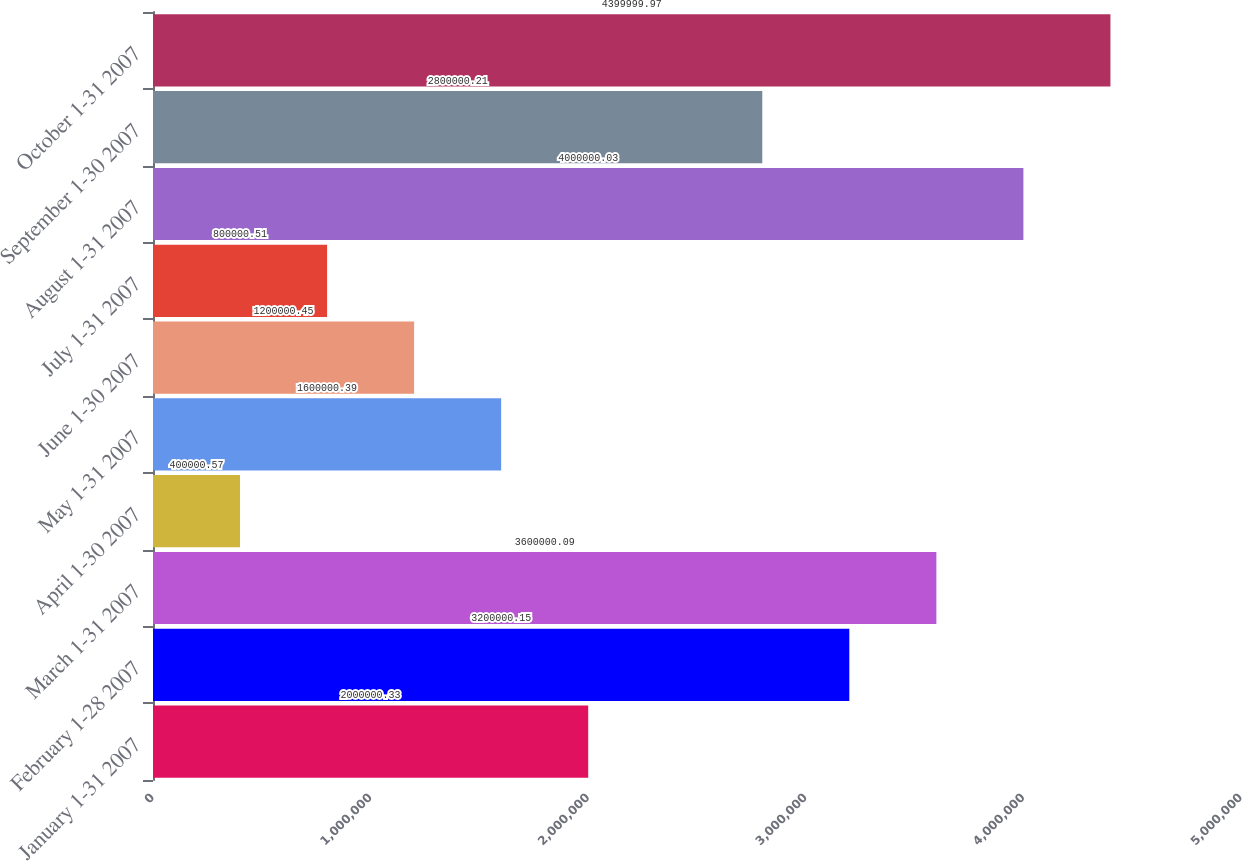Convert chart to OTSL. <chart><loc_0><loc_0><loc_500><loc_500><bar_chart><fcel>January 1-31 2007<fcel>February 1-28 2007<fcel>March 1-31 2007<fcel>April 1-30 2007<fcel>May 1-31 2007<fcel>June 1-30 2007<fcel>July 1-31 2007<fcel>August 1-31 2007<fcel>September 1-30 2007<fcel>October 1-31 2007<nl><fcel>2e+06<fcel>3.2e+06<fcel>3.6e+06<fcel>400001<fcel>1.6e+06<fcel>1.2e+06<fcel>800001<fcel>4e+06<fcel>2.8e+06<fcel>4.4e+06<nl></chart> 